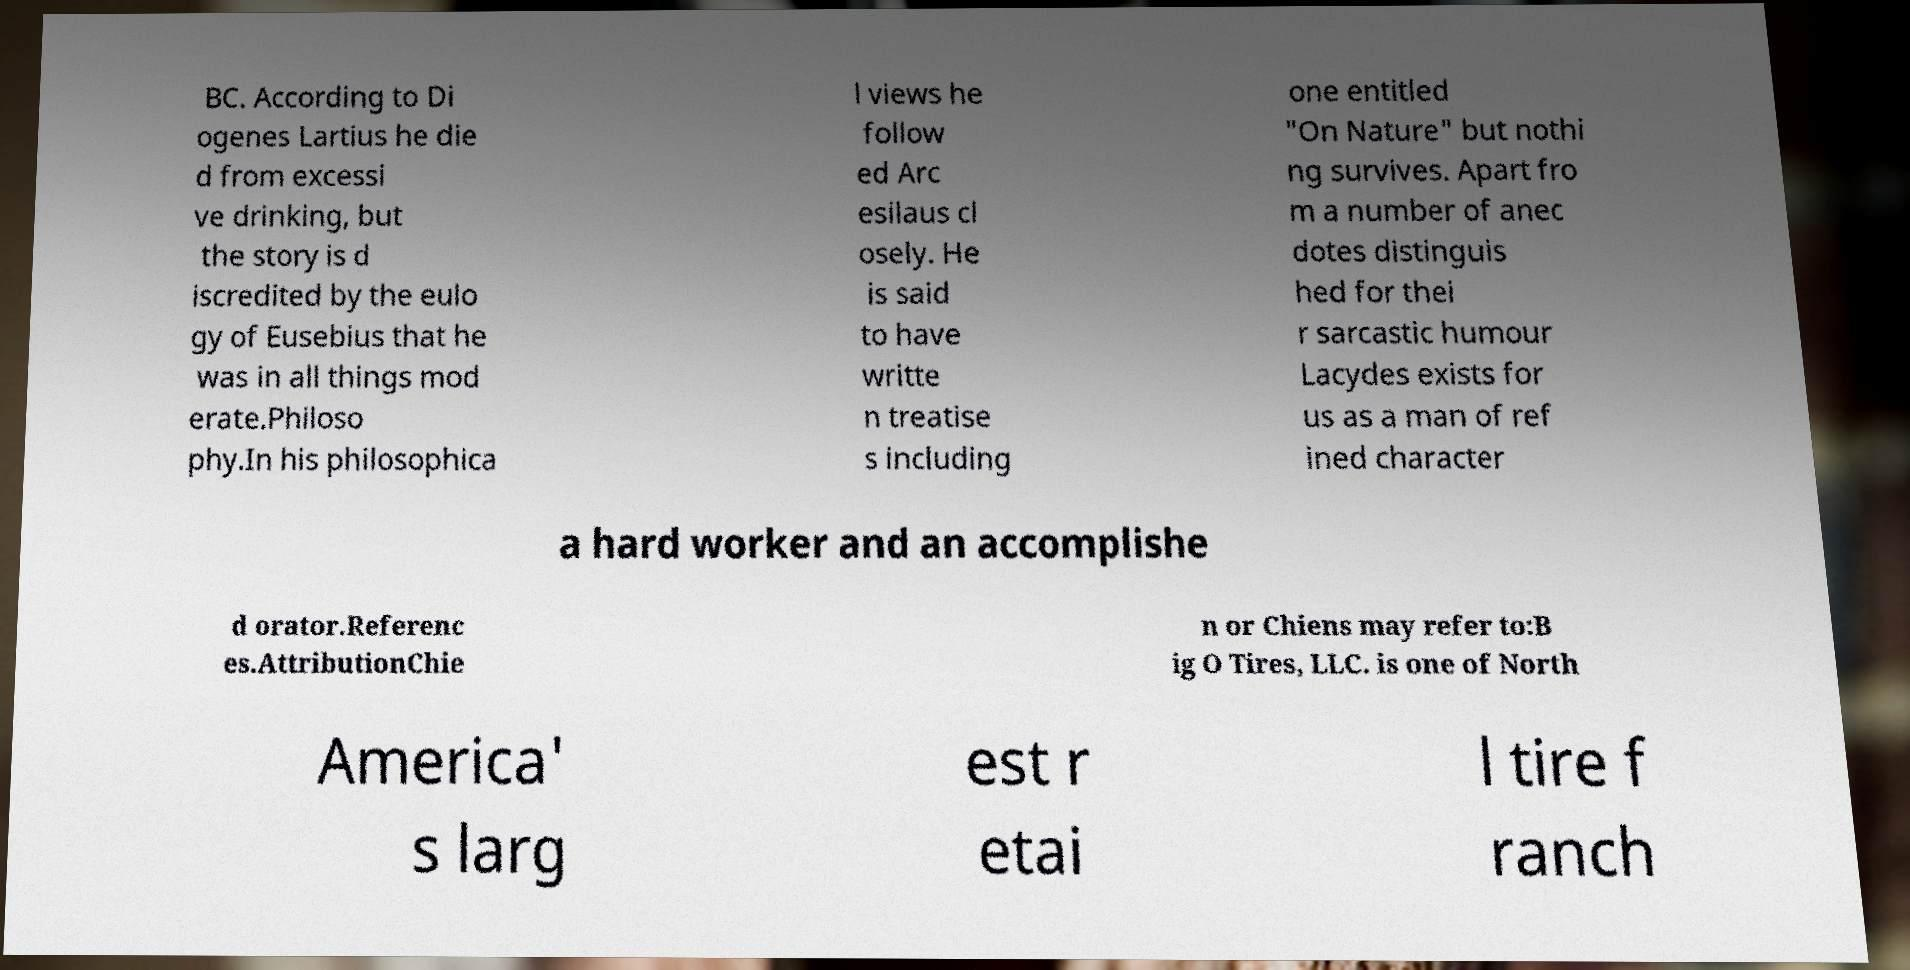Please read and relay the text visible in this image. What does it say? BC. According to Di ogenes Lartius he die d from excessi ve drinking, but the story is d iscredited by the eulo gy of Eusebius that he was in all things mod erate.Philoso phy.In his philosophica l views he follow ed Arc esilaus cl osely. He is said to have writte n treatise s including one entitled "On Nature" but nothi ng survives. Apart fro m a number of anec dotes distinguis hed for thei r sarcastic humour Lacydes exists for us as a man of ref ined character a hard worker and an accomplishe d orator.Referenc es.AttributionChie n or Chiens may refer to:B ig O Tires, LLC. is one of North America' s larg est r etai l tire f ranch 